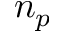<formula> <loc_0><loc_0><loc_500><loc_500>n _ { p }</formula> 